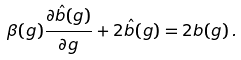Convert formula to latex. <formula><loc_0><loc_0><loc_500><loc_500>\beta ( g ) \frac { \partial \hat { b } ( g ) } { \partial g } + 2 \hat { b } ( g ) = 2 b ( g ) \, .</formula> 